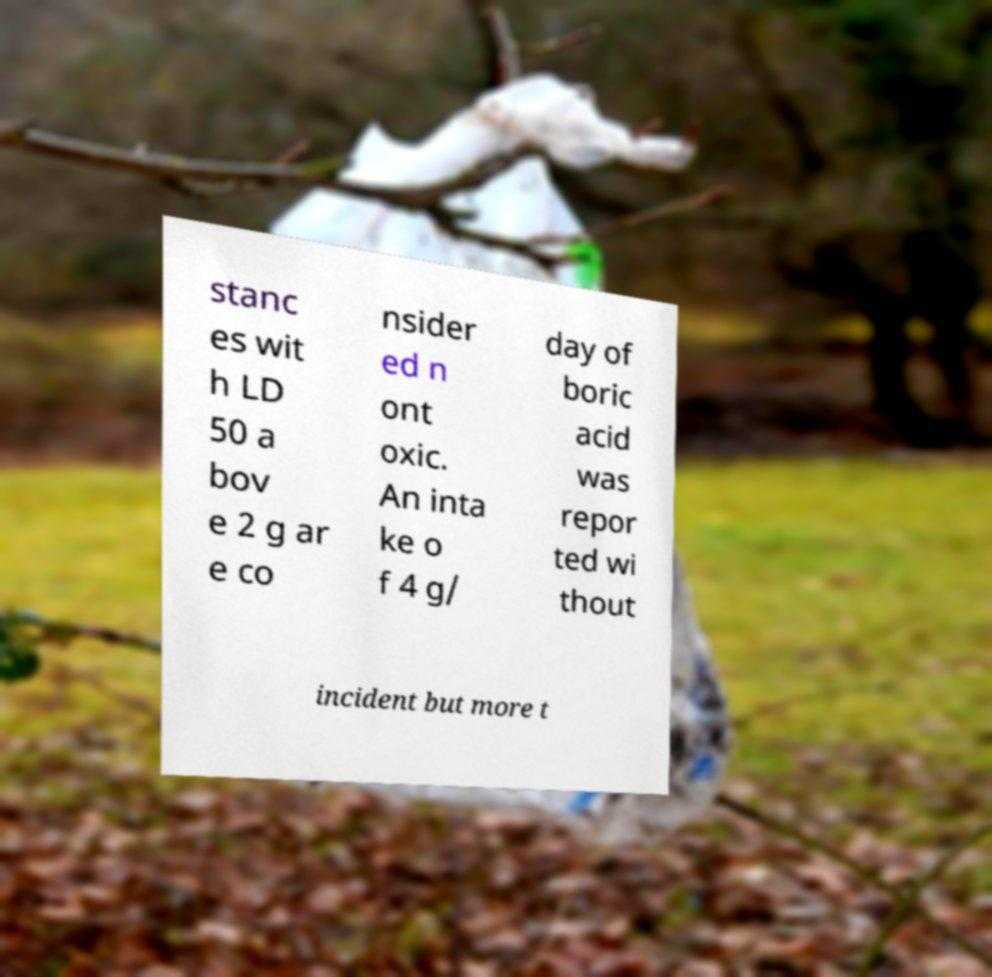What messages or text are displayed in this image? I need them in a readable, typed format. stanc es wit h LD 50 a bov e 2 g ar e co nsider ed n ont oxic. An inta ke o f 4 g/ day of boric acid was repor ted wi thout incident but more t 